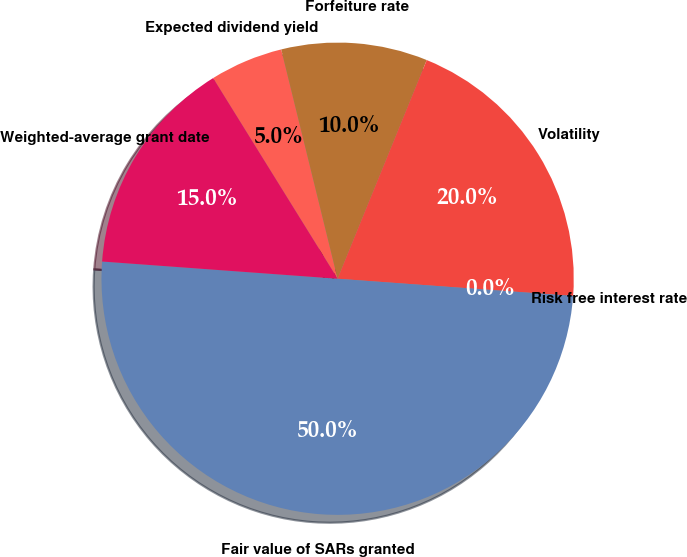Convert chart to OTSL. <chart><loc_0><loc_0><loc_500><loc_500><pie_chart><fcel>Expected dividend yield<fcel>Forfeiture rate<fcel>Volatility<fcel>Risk free interest rate<fcel>Fair value of SARs granted<fcel>Weighted-average grant date<nl><fcel>5.0%<fcel>10.0%<fcel>20.0%<fcel>0.0%<fcel>50.0%<fcel>15.0%<nl></chart> 